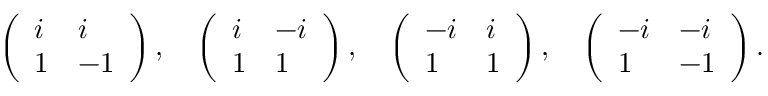Convert formula to latex. <formula><loc_0><loc_0><loc_500><loc_500>\left ( \begin{array} { l l } { i } & { i } \\ { 1 } & { - 1 } \end{array} \right ) , \quad l e f t ( \begin{array} { l l } { i } & { - i } \\ { 1 } & { 1 } \end{array} \right ) , \quad l e f t ( \begin{array} { l l } { - i } & { i } \\ { 1 } & { 1 } \end{array} \right ) , \quad l e f t ( \begin{array} { l l } { - i } & { - i } \\ { 1 } & { - 1 } \end{array} \right ) .</formula> 